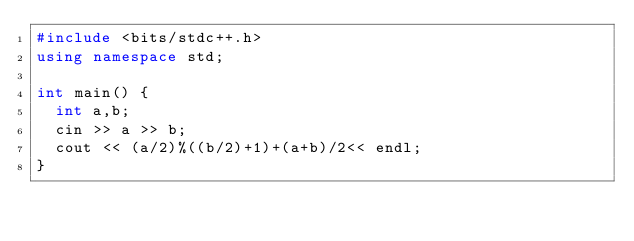<code> <loc_0><loc_0><loc_500><loc_500><_C++_>#include <bits/stdc++.h>
using namespace std;
 
int main() {
  int a,b;
  cin >> a >> b;
  cout << (a/2)%((b/2)+1)+(a+b)/2<< endl;
}</code> 